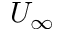<formula> <loc_0><loc_0><loc_500><loc_500>U _ { \infty }</formula> 